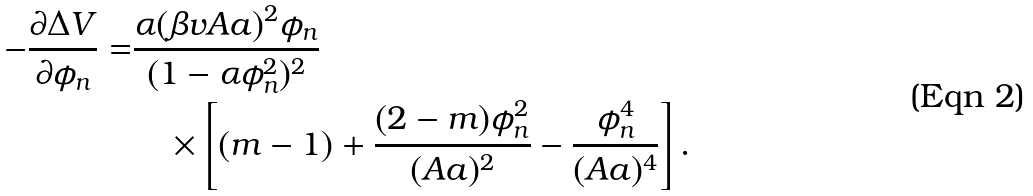<formula> <loc_0><loc_0><loc_500><loc_500>- \frac { \partial \Delta V } { \partial \phi _ { n } } = & \frac { \alpha ( \beta v A a ) ^ { 2 } \phi _ { n } } { ( 1 - \alpha \phi _ { n } ^ { 2 } ) ^ { 2 } } \\ & \quad \times \left [ ( m - 1 ) + \frac { ( 2 - m ) \phi _ { n } ^ { 2 } } { ( A a ) ^ { 2 } } - \frac { \phi _ { n } ^ { 4 } } { ( A a ) ^ { 4 } } \right ] .</formula> 